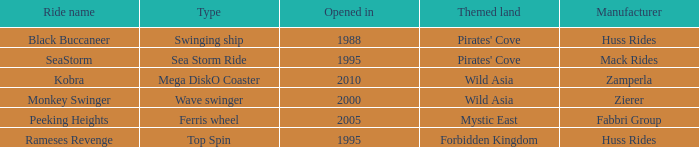What category of ride does rameses revenge belong to? Top Spin. 